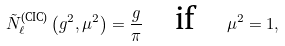<formula> <loc_0><loc_0><loc_500><loc_500>\tilde { N } _ { \ell } ^ { \text {(CIC)} } \left ( g ^ { 2 } , \mu ^ { 2 } \right ) = \frac { g } { \pi } \quad \text {if} \quad \mu ^ { 2 } = 1 ,</formula> 